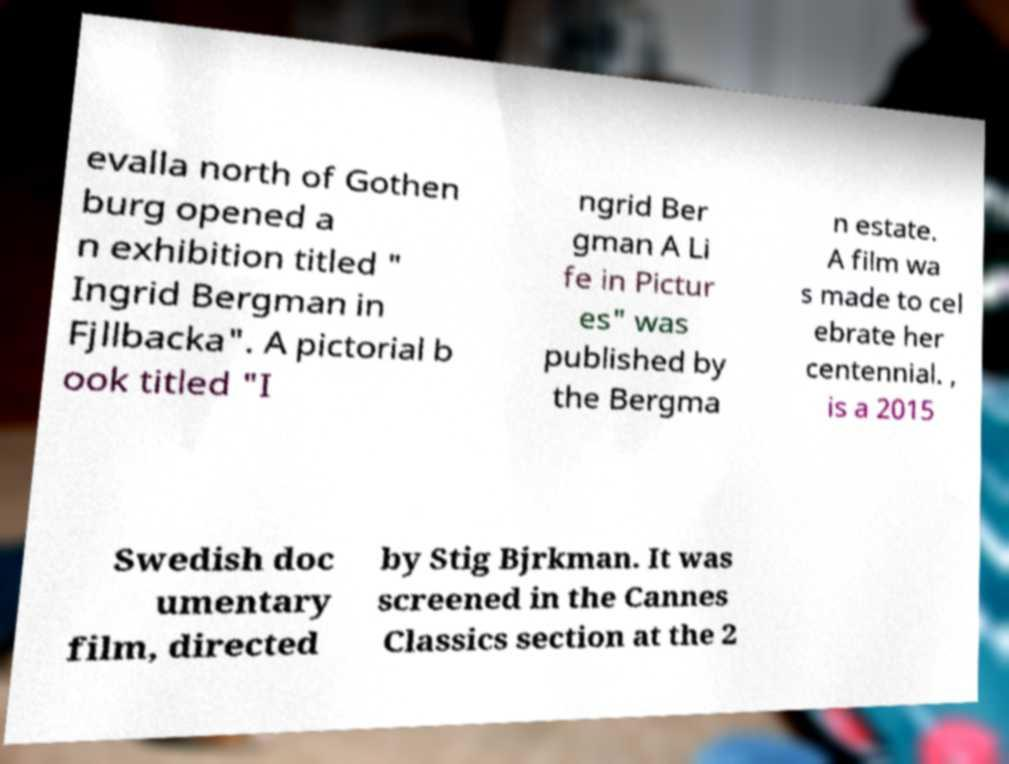For documentation purposes, I need the text within this image transcribed. Could you provide that? evalla north of Gothen burg opened a n exhibition titled " Ingrid Bergman in Fjllbacka". A pictorial b ook titled "I ngrid Ber gman A Li fe in Pictur es" was published by the Bergma n estate. A film wa s made to cel ebrate her centennial. , is a 2015 Swedish doc umentary film, directed by Stig Bjrkman. It was screened in the Cannes Classics section at the 2 